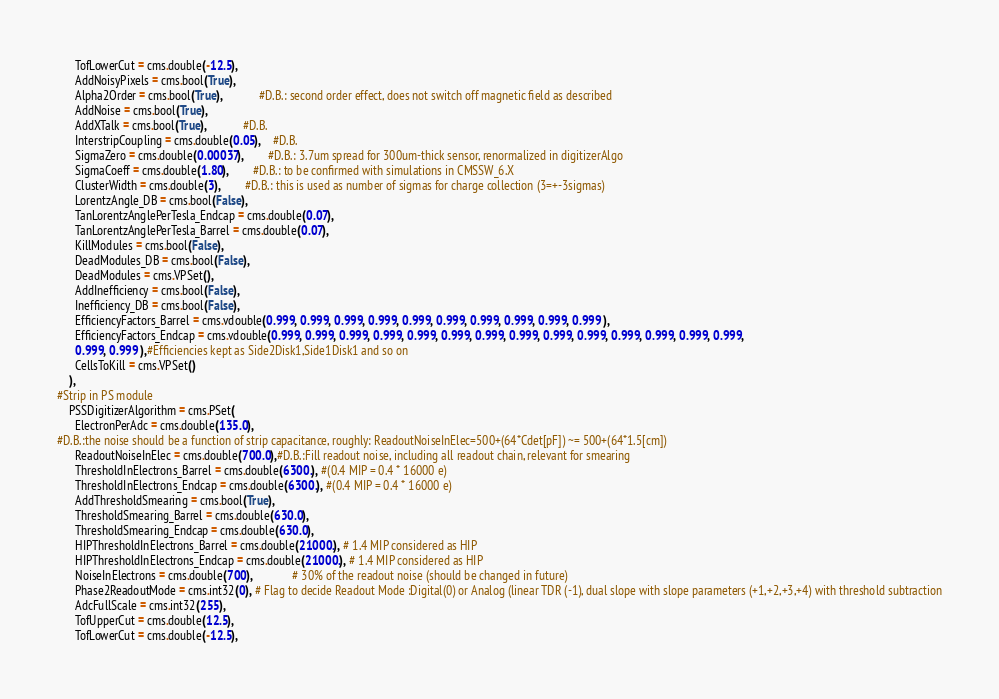Convert code to text. <code><loc_0><loc_0><loc_500><loc_500><_Python_>      TofLowerCut = cms.double(-12.5),
      AddNoisyPixels = cms.bool(True),
      Alpha2Order = cms.bool(True),			#D.B.: second order effect, does not switch off magnetic field as described
      AddNoise = cms.bool(True),
      AddXTalk = cms.bool(True),			#D.B.
      InterstripCoupling = cms.double(0.05),	#D.B.
      SigmaZero = cms.double(0.00037),  		#D.B.: 3.7um spread for 300um-thick sensor, renormalized in digitizerAlgo
      SigmaCoeff = cms.double(1.80),  		#D.B.: to be confirmed with simulations in CMSSW_6.X
      ClusterWidth = cms.double(3),		#D.B.: this is used as number of sigmas for charge collection (3=+-3sigmas)
      LorentzAngle_DB = cms.bool(False),			
      TanLorentzAnglePerTesla_Endcap = cms.double(0.07),
      TanLorentzAnglePerTesla_Barrel = cms.double(0.07),
      KillModules = cms.bool(False),
      DeadModules_DB = cms.bool(False),
      DeadModules = cms.VPSet(),
      AddInefficiency = cms.bool(False),
      Inefficiency_DB = cms.bool(False),				
      EfficiencyFactors_Barrel = cms.vdouble(0.999, 0.999, 0.999, 0.999, 0.999, 0.999, 0.999, 0.999, 0.999, 0.999 ),
      EfficiencyFactors_Endcap = cms.vdouble(0.999, 0.999, 0.999, 0.999, 0.999, 0.999, 0.999, 0.999, 0.999, 0.999, 0.999, 0.999, 0.999, 0.999, 
      0.999, 0.999 ),#Efficiencies kept as Side2Disk1,Side1Disk1 and so on
      CellsToKill = cms.VPSet()
    ),
#Strip in PS module
    PSSDigitizerAlgorithm = cms.PSet(
      ElectronPerAdc = cms.double(135.0),
#D.B.:the noise should be a function of strip capacitance, roughly: ReadoutNoiseInElec=500+(64*Cdet[pF]) ~= 500+(64*1.5[cm])
      ReadoutNoiseInElec = cms.double(700.0),#D.B.:Fill readout noise, including all readout chain, relevant for smearing
      ThresholdInElectrons_Barrel = cms.double(6300.), #(0.4 MIP = 0.4 * 16000 e)
      ThresholdInElectrons_Endcap = cms.double(6300.), #(0.4 MIP = 0.4 * 16000 e)
      AddThresholdSmearing = cms.bool(True),
      ThresholdSmearing_Barrel = cms.double(630.0),
      ThresholdSmearing_Endcap = cms.double(630.0),
      HIPThresholdInElectrons_Barrel = cms.double(21000.), # 1.4 MIP considered as HIP
      HIPThresholdInElectrons_Endcap = cms.double(21000.), # 1.4 MIP considered as HIP 
      NoiseInElectrons = cms.double(700),	         # 30% of the readout noise (should be changed in future)
      Phase2ReadoutMode = cms.int32(0), # Flag to decide Readout Mode :Digital(0) or Analog (linear TDR (-1), dual slope with slope parameters (+1,+2,+3,+4) with threshold subtraction
      AdcFullScale = cms.int32(255),
      TofUpperCut = cms.double(12.5),
      TofLowerCut = cms.double(-12.5),</code> 